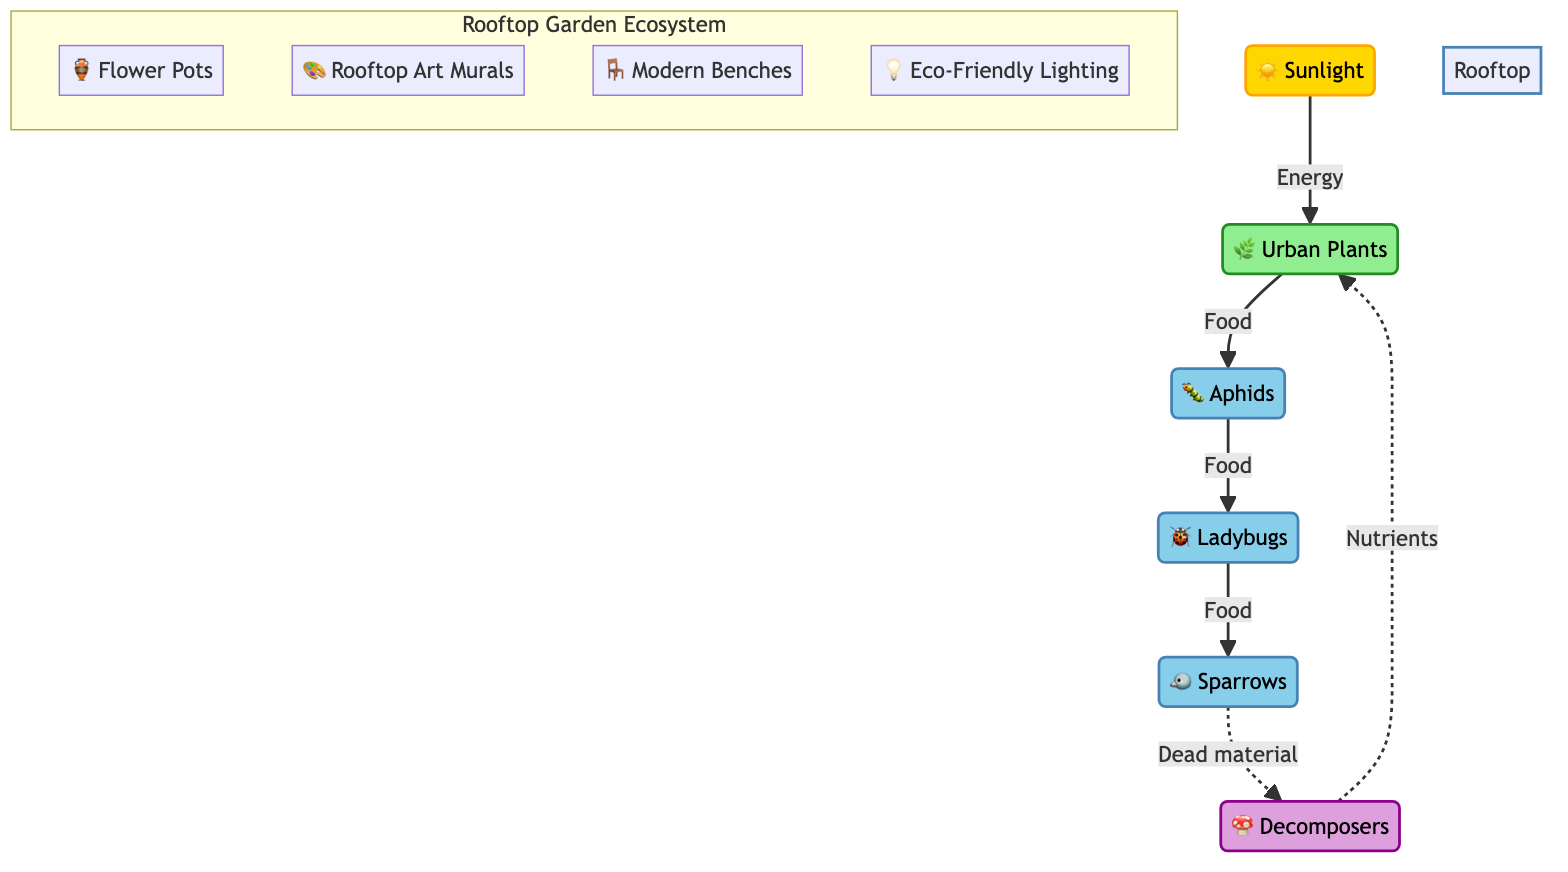What is the source of energy in the rooftop garden ecosystem? The diagram shows that the source of energy is represented by the "☀️ Sunlight" node. This node directly connects to "🌿 Urban Plants," indicating that the sunlight provides energy for plant growth.
Answer: Sunlight How many consumer nodes are present in the diagram? The diagram includes three consumer nodes: "🐛 Aphids," "🐞 Ladybugs," and "🐦 Sparrows." By counting these nodes, we find that there are a total of three consumers in the ecosystem.
Answer: 3 What type of relationship exists between Ladybugs and Sparrows? The diagram indicates a direct relationship where "🐞 Ladybugs" provide food for "🐦 Sparrows." This shows that Ladybugs are a food resource for Sparrows, categorizing their relationship as predator-prey.
Answer: Food Which element decomposes dead material in the ecosystem? The diagram identifies "🍄 Decomposers" as responsible for decomposing dead material contributed by Sparrows. This indicates their role in nutrient recycling within the rooftop garden ecosystem.
Answer: Decomposers How do Decomposers benefit Urban Plants? According to the diagram, "🍄 Decomposers" break down dead material, leading to the release of nutrients. These nutrients then circulate back into the "🌿 Urban Plants," demonstrating the interdependence for growth and vitality.
Answer: Nutrients What role do Urban Plants play in the food chain? The "🌿 Urban Plants" are identified as the primary producers in the food chain. They convert sunlight into energy, serving as the foundational food source for subsequent consumer levels, initiating the energy flow.
Answer: Producer Which decorative feature in the rooftop garden ecosystem is represented by modern benches? The diagram includes "🪑 Modern Benches" as part of the rooftop garden's decorative elements but does not directly impact the food chain. Their presence enhances the aesthetic and functionality of the garden space.
Answer: Modern Benches What do Aphids consume in this ecosystem? The diagram directly indicates that "🐛 Aphids" feed on "🌿 Urban Plants." This relationship depicts Aphids as herbivores that rely on the plants for sustenance within the ecosystem.
Answer: Urban Plants 